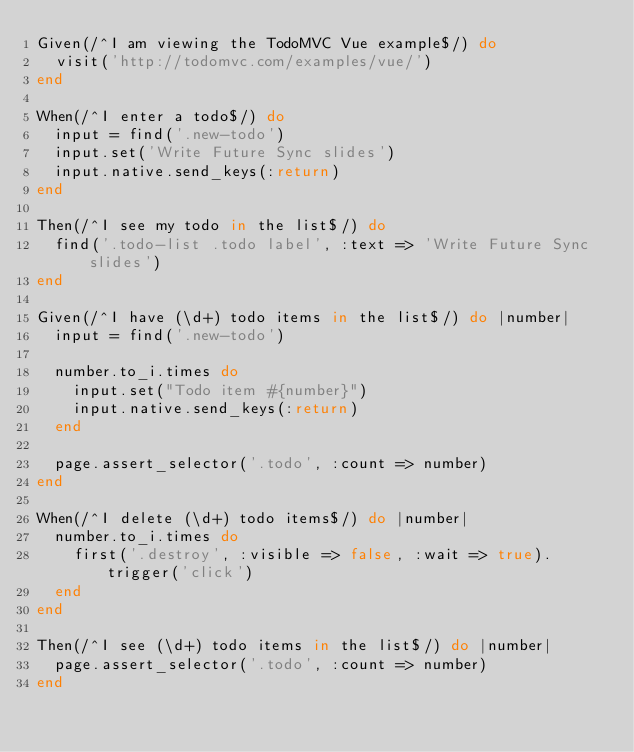Convert code to text. <code><loc_0><loc_0><loc_500><loc_500><_Ruby_>Given(/^I am viewing the TodoMVC Vue example$/) do
  visit('http://todomvc.com/examples/vue/')
end

When(/^I enter a todo$/) do
  input = find('.new-todo')
  input.set('Write Future Sync slides')
  input.native.send_keys(:return)
end

Then(/^I see my todo in the list$/) do
  find('.todo-list .todo label', :text => 'Write Future Sync slides')
end

Given(/^I have (\d+) todo items in the list$/) do |number|
  input = find('.new-todo')

  number.to_i.times do
    input.set("Todo item #{number}")
    input.native.send_keys(:return)
  end

  page.assert_selector('.todo', :count => number)
end

When(/^I delete (\d+) todo items$/) do |number|
  number.to_i.times do
    first('.destroy', :visible => false, :wait => true).trigger('click')
  end
end

Then(/^I see (\d+) todo items in the list$/) do |number|
  page.assert_selector('.todo', :count => number)
end
</code> 